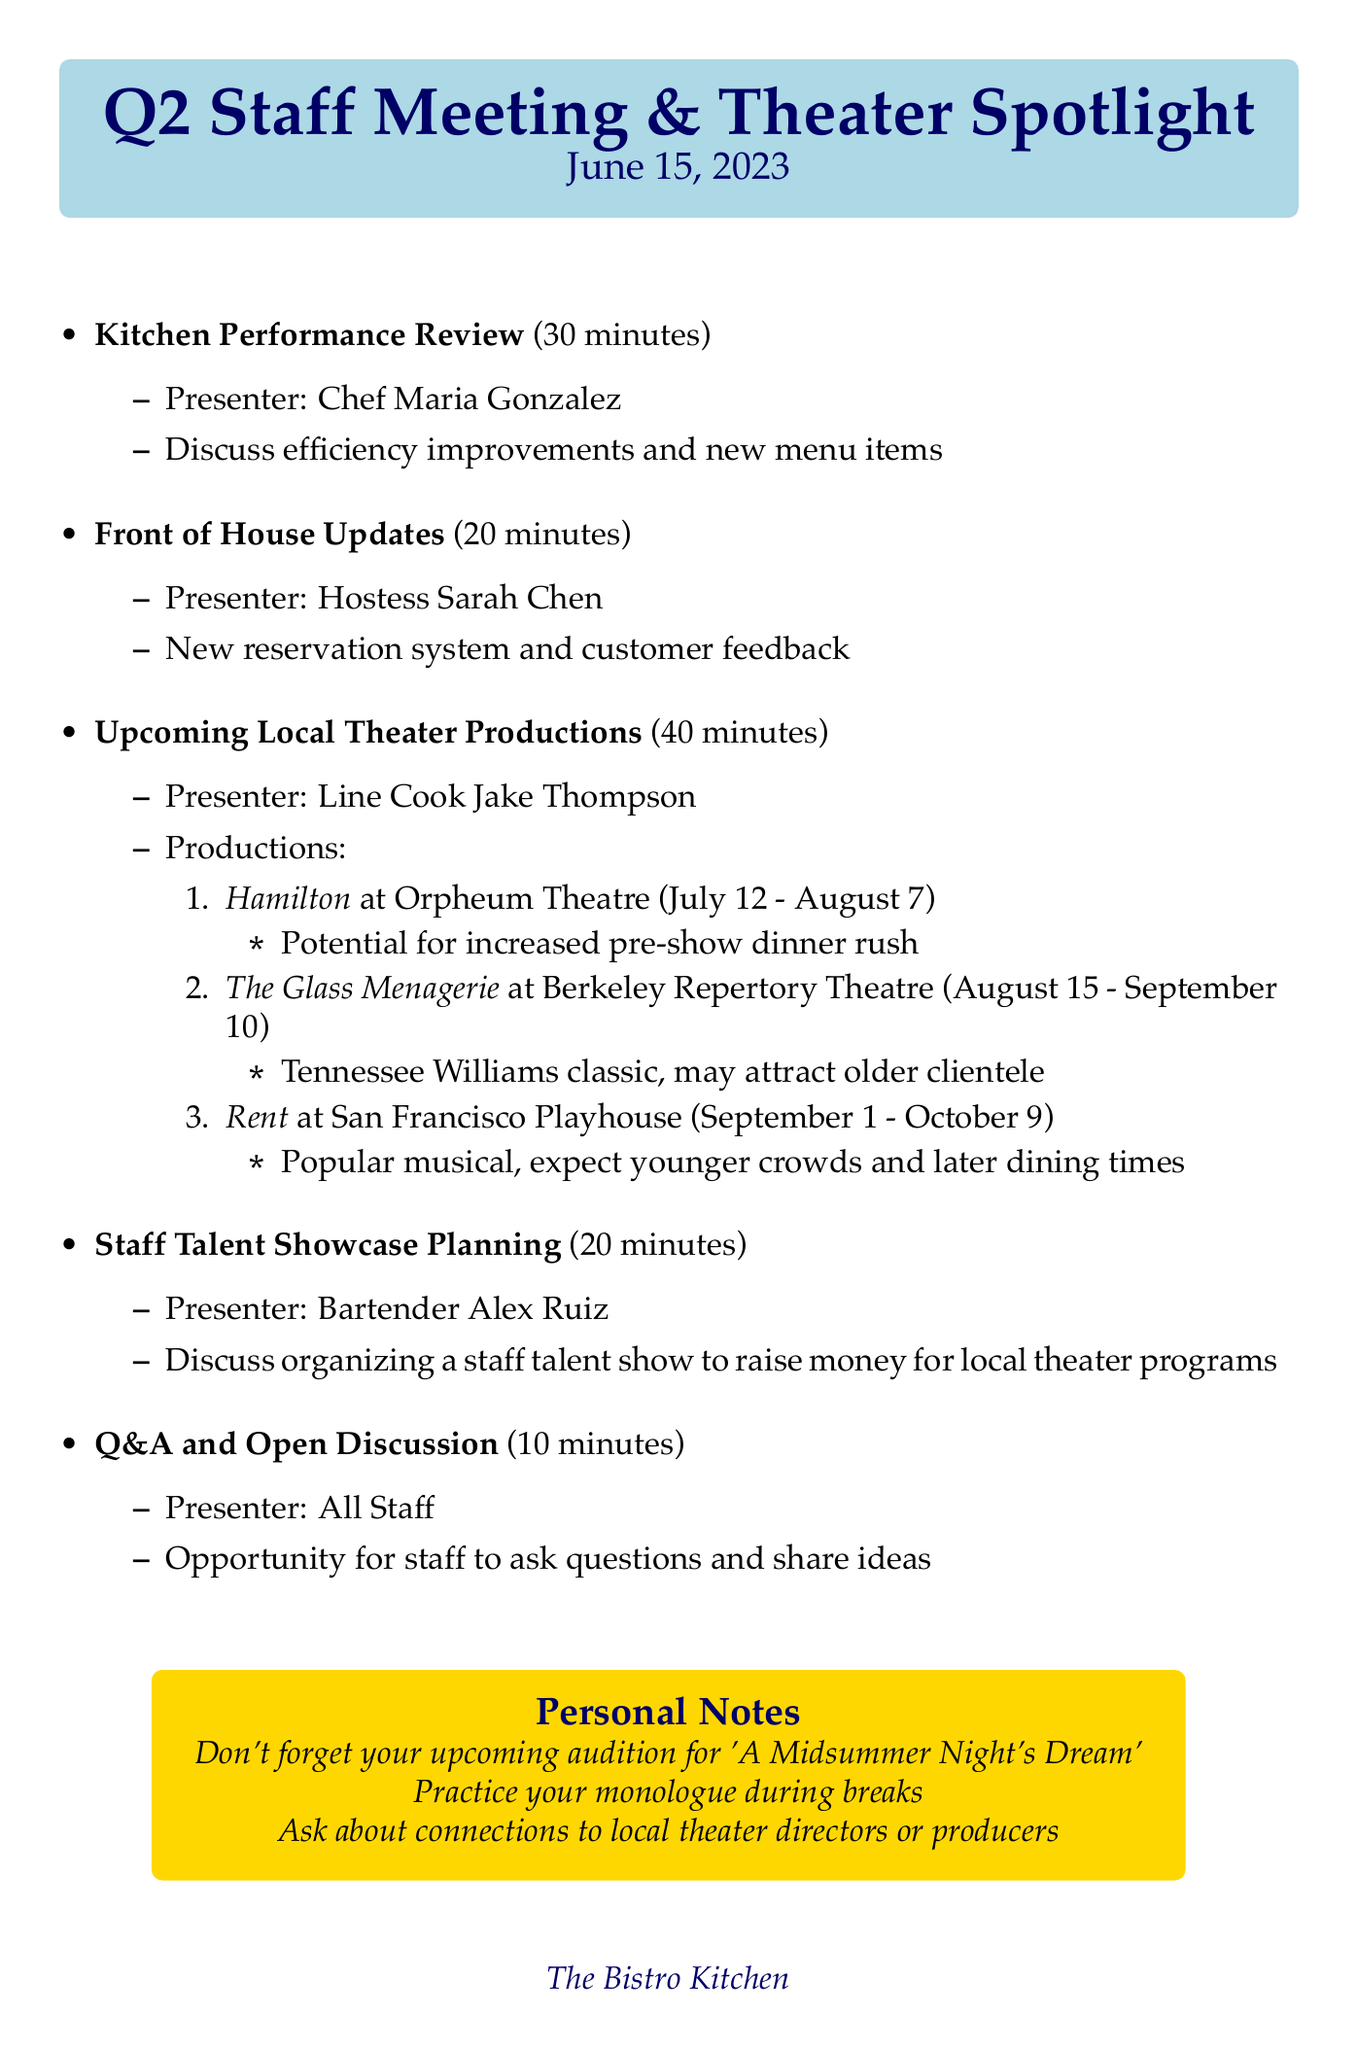What is the date of the meeting? The date of the meeting is explicitly stated in the document.
Answer: June 15, 2023 Who is the presenter for the "Kitchen Performance Review"? The presenter is mentioned under the respective agenda item.
Answer: Chef Maria Gonzalez How long is the "Upcoming Local Theater Productions" agenda item? The duration of each agenda item is specified in the document.
Answer: 40 minutes What is one of the theater productions mentioned? The document lists several productions under the respective agenda item.
Answer: Hamilton What is the venue for "The Glass Menagerie"? The venue is provided along with each production in the agenda item.
Answer: Berkeley Repertory Theatre Which agenda item is focused on staff talent showcase? The document outlines various agenda items, clearly showing the focus of each.
Answer: Staff Talent Showcase Planning How many productions are listed under the "Upcoming Local Theater Productions"? The number of productions can be counted from the list in the document.
Answer: 3 What is one personal note mentioned in the document? The personal notes section captures specific reminders related to the meeting.
Answer: Don't forget to mention your upcoming audition for 'A Midsummer Night's Dream' 